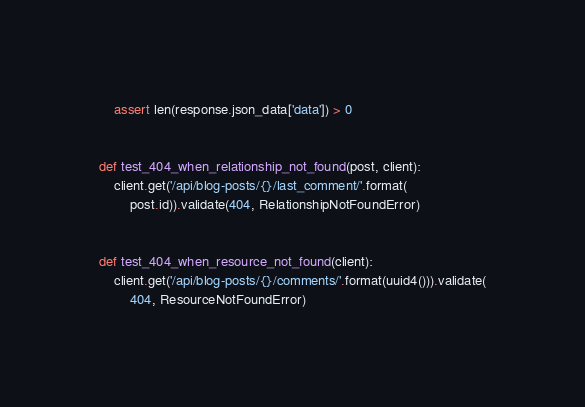<code> <loc_0><loc_0><loc_500><loc_500><_Python_>    assert len(response.json_data['data']) > 0


def test_404_when_relationship_not_found(post, client):
    client.get('/api/blog-posts/{}/last_comment/'.format(
        post.id)).validate(404, RelationshipNotFoundError)


def test_404_when_resource_not_found(client):
    client.get('/api/blog-posts/{}/comments/'.format(uuid4())).validate(
        404, ResourceNotFoundError)
</code> 